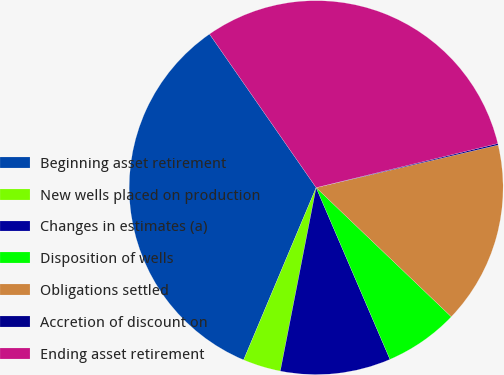Convert chart. <chart><loc_0><loc_0><loc_500><loc_500><pie_chart><fcel>Beginning asset retirement<fcel>New wells placed on production<fcel>Changes in estimates (a)<fcel>Disposition of wells<fcel>Obligations settled<fcel>Accretion of discount on<fcel>Ending asset retirement<nl><fcel>34.0%<fcel>3.27%<fcel>9.53%<fcel>6.4%<fcel>15.8%<fcel>0.13%<fcel>30.87%<nl></chart> 